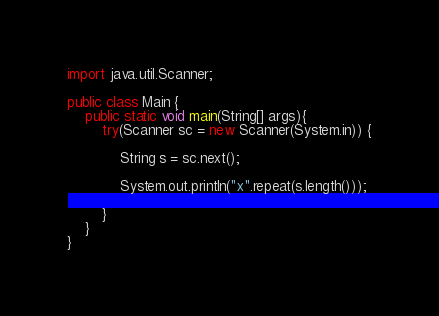Convert code to text. <code><loc_0><loc_0><loc_500><loc_500><_Java_>import java.util.Scanner;

public class Main {
	public static void main(String[] args){
		try(Scanner sc = new Scanner(System.in)) {
			
			String s = sc.next();
			
			System.out.println("x".repeat(s.length()));
			
		}
	}
}</code> 